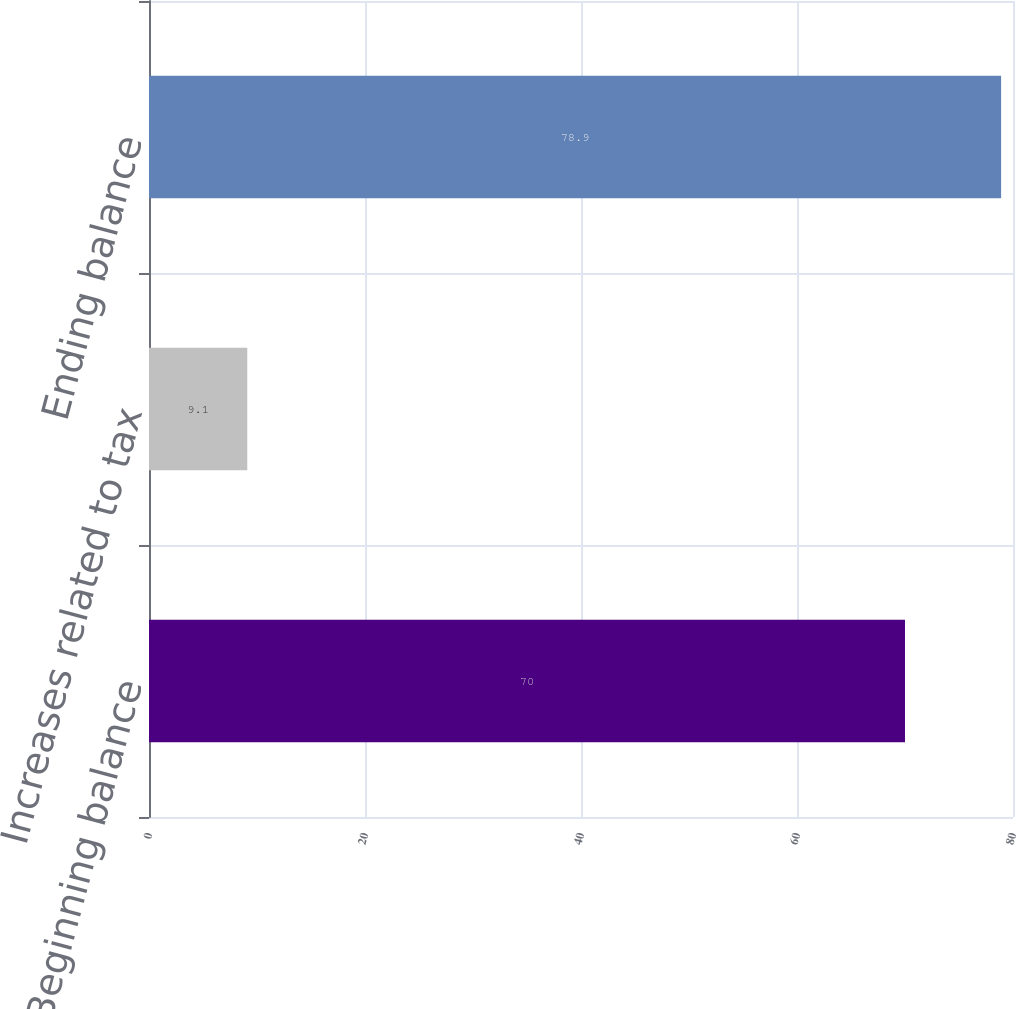Convert chart. <chart><loc_0><loc_0><loc_500><loc_500><bar_chart><fcel>Beginning balance<fcel>Increases related to tax<fcel>Ending balance<nl><fcel>70<fcel>9.1<fcel>78.9<nl></chart> 